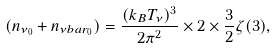Convert formula to latex. <formula><loc_0><loc_0><loc_500><loc_500>( n _ { \nu _ { 0 } } + n _ { \nu b a r _ { 0 } } ) = \frac { ( k _ { B } T _ { \nu } ) ^ { 3 } } { 2 \pi ^ { 2 } } \times 2 \times \frac { 3 } { 2 } \zeta ( 3 ) ,</formula> 